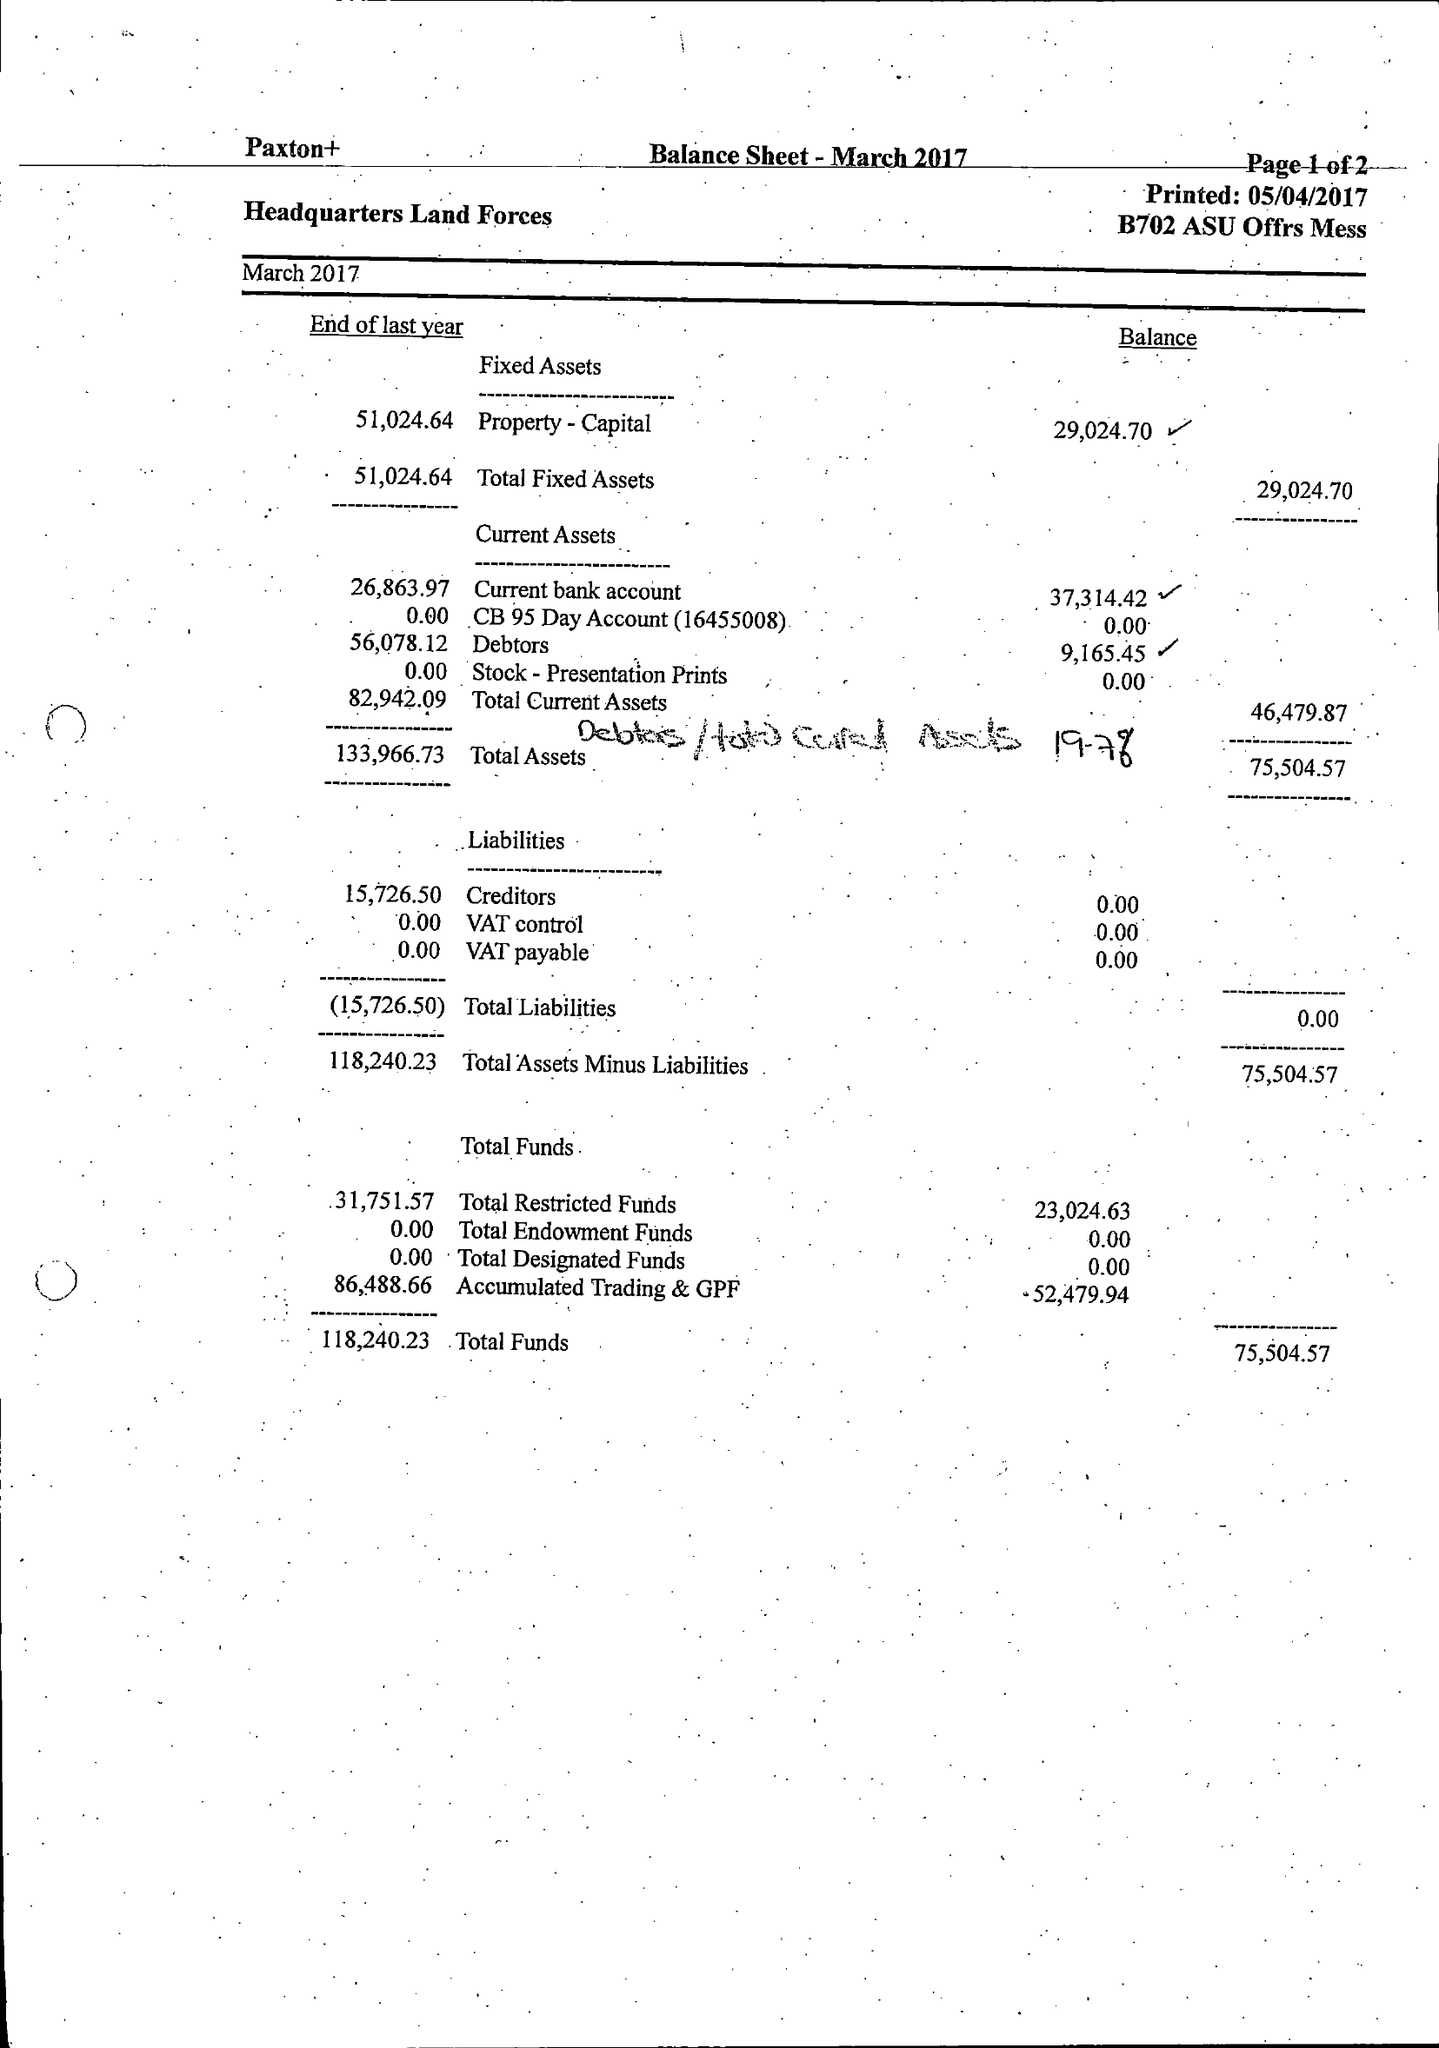What is the value for the charity_name?
Answer the question using a single word or phrase. Land Forces Hq 